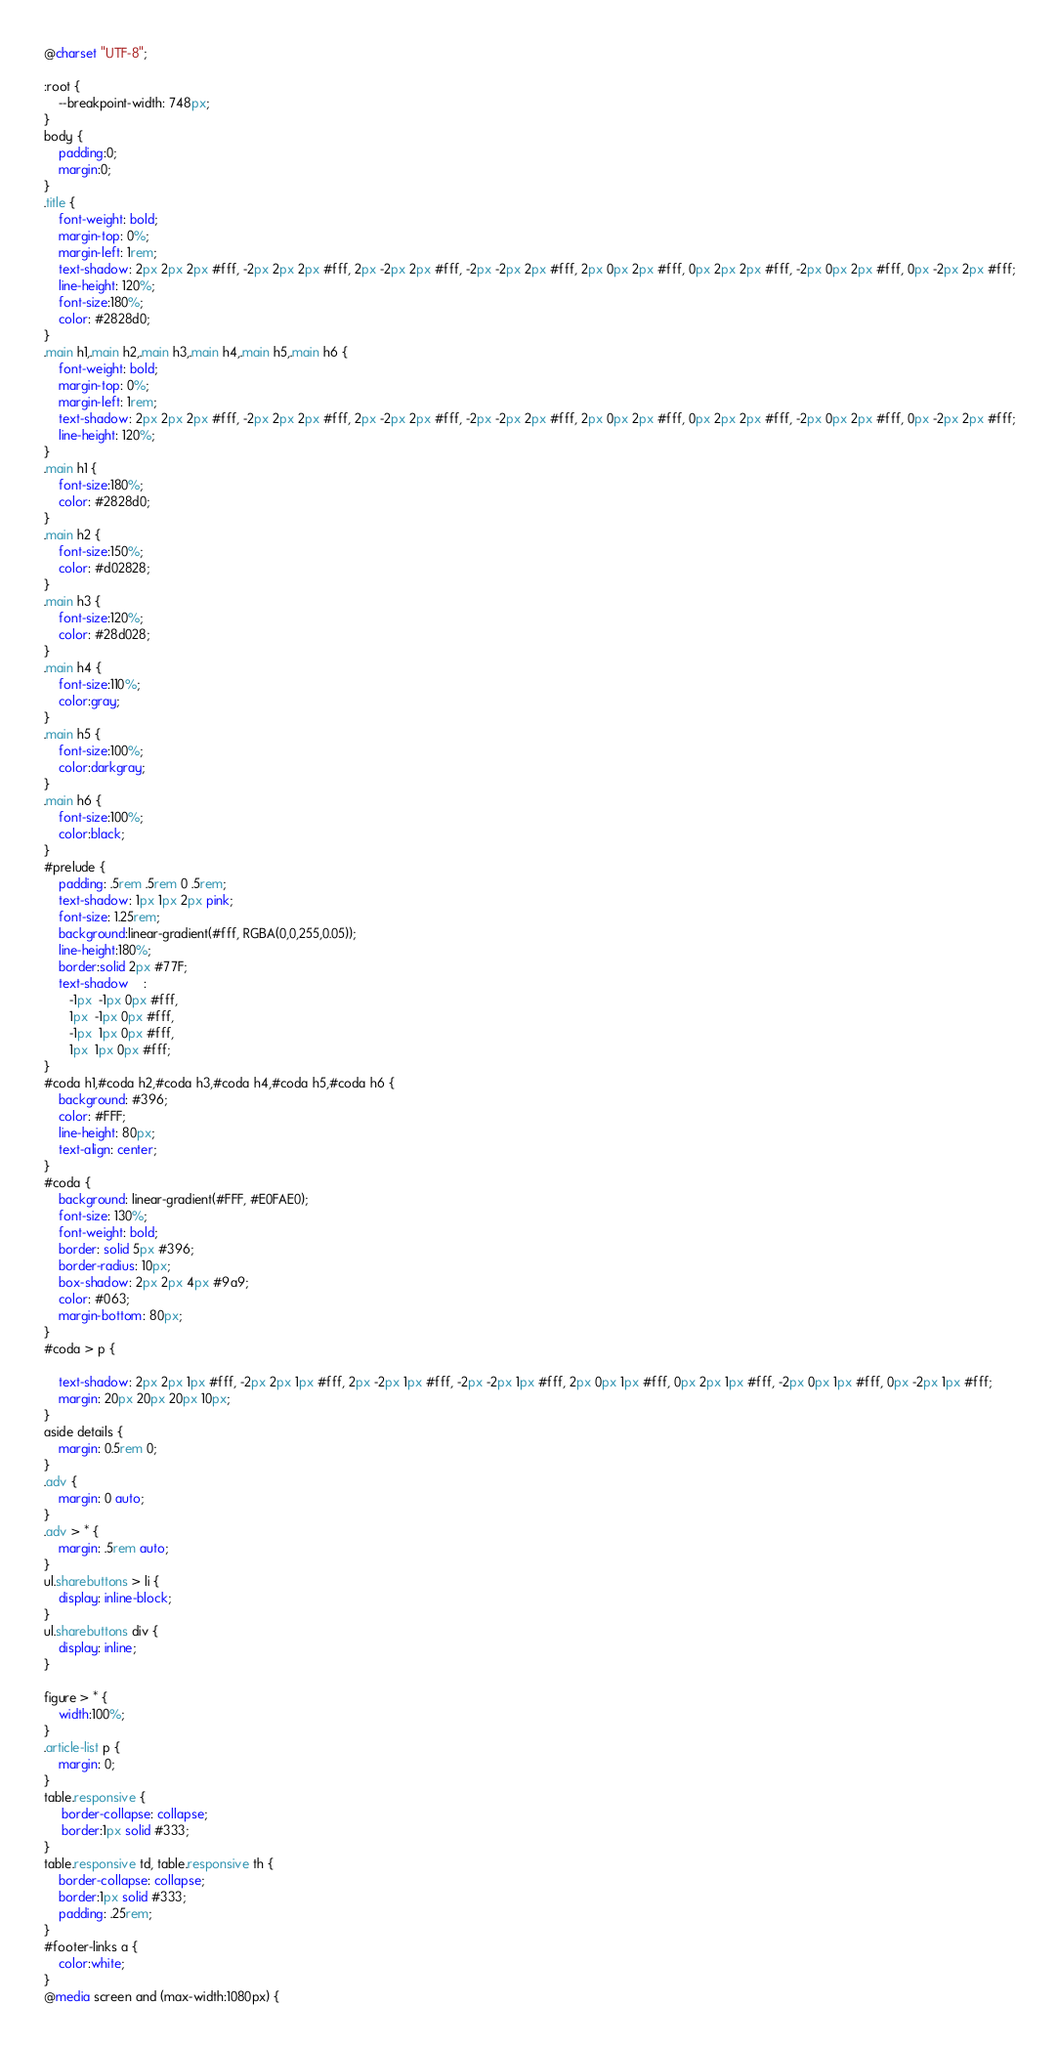Convert code to text. <code><loc_0><loc_0><loc_500><loc_500><_CSS_>@charset "UTF-8";

:root {
	--breakpoint-width: 748px;
}
body {
	padding:0;
	margin:0;
}
.title {
    font-weight: bold;
    margin-top: 0%;
    margin-left: 1rem;
    text-shadow: 2px 2px 2px #fff, -2px 2px 2px #fff, 2px -2px 2px #fff, -2px -2px 2px #fff, 2px 0px 2px #fff, 0px 2px 2px #fff, -2px 0px 2px #fff, 0px -2px 2px #fff;
    line-height: 120%;
	font-size:180%;
    color: #2828d0;
}
.main h1,.main h2,.main h3,.main h4,.main h5,.main h6 {
    font-weight: bold;
    margin-top: 0%;
    margin-left: 1rem;
    text-shadow: 2px 2px 2px #fff, -2px 2px 2px #fff, 2px -2px 2px #fff, -2px -2px 2px #fff, 2px 0px 2px #fff, 0px 2px 2px #fff, -2px 0px 2px #fff, 0px -2px 2px #fff;
    line-height: 120%;
}
.main h1 {
	font-size:180%;
    color: #2828d0;
}
.main h2 {
	font-size:150%;
	color: #d02828;
}
.main h3 {
	font-size:120%;
	color: #28d028;
}
.main h4 {
	font-size:110%;
	color:gray;
}
.main h5 {
	font-size:100%;
	color:darkgray;
}
.main h6 {
	font-size:100%;
	color:black;
}
#prelude {
	padding: .5rem .5rem 0 .5rem;
	text-shadow: 1px 1px 2px pink;
	font-size: 1.25rem;
	background:linear-gradient(#fff, RGBA(0,0,255,0.05));
	line-height:180%;                
	border:solid 2px #77F;
	text-shadow    : 
       -1px  -1px 0px #fff,
       1px  -1px 0px #fff,
       -1px  1px 0px #fff,
       1px  1px 0px #fff;
}
#coda h1,#coda h2,#coda h3,#coda h4,#coda h5,#coda h6 {
    background: #396;
    color: #FFF;
    line-height: 80px;
    text-align: center;
}
#coda {
    background: linear-gradient(#FFF, #E0FAE0);
    font-size: 130%;
    font-weight: bold;
    border: solid 5px #396;
    border-radius: 10px;
    box-shadow: 2px 2px 4px #9a9;
    color: #063;
    margin-bottom: 80px;
}                            
#coda > p {

    text-shadow: 2px 2px 1px #fff, -2px 2px 1px #fff, 2px -2px 1px #fff, -2px -2px 1px #fff, 2px 0px 1px #fff, 0px 2px 1px #fff, -2px 0px 1px #fff, 0px -2px 1px #fff;
    margin: 20px 20px 20px 10px;
}
aside details {
	margin: 0.5rem 0;
}
.adv {
	margin: 0 auto;
}               
.adv > * {                          
	margin: .5rem auto;
}
ul.sharebuttons > li {
	display: inline-block;
}
ul.sharebuttons div {
	display: inline;
}

figure > * {
	width:100%;
}
.article-list p {
	margin: 0;
}
table.responsive {
	 border-collapse: collapse;
	 border:1px solid #333;
}
table.responsive td, table.responsive th {
	border-collapse: collapse;
	border:1px solid #333;
	padding: .25rem;
}
#footer-links a {
	color:white;
}
@media screen and (max-width:1080px) {</code> 